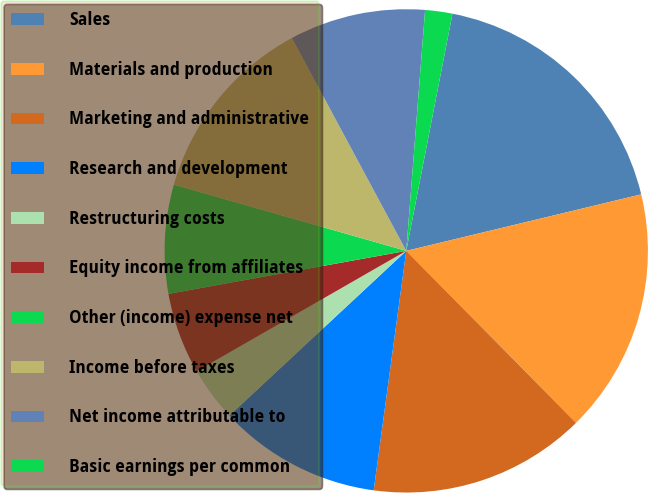<chart> <loc_0><loc_0><loc_500><loc_500><pie_chart><fcel>Sales<fcel>Materials and production<fcel>Marketing and administrative<fcel>Research and development<fcel>Restructuring costs<fcel>Equity income from affiliates<fcel>Other (income) expense net<fcel>Income before taxes<fcel>Net income attributable to<fcel>Basic earnings per common<nl><fcel>18.18%<fcel>16.36%<fcel>14.55%<fcel>10.91%<fcel>3.64%<fcel>5.45%<fcel>7.27%<fcel>12.73%<fcel>9.09%<fcel>1.82%<nl></chart> 